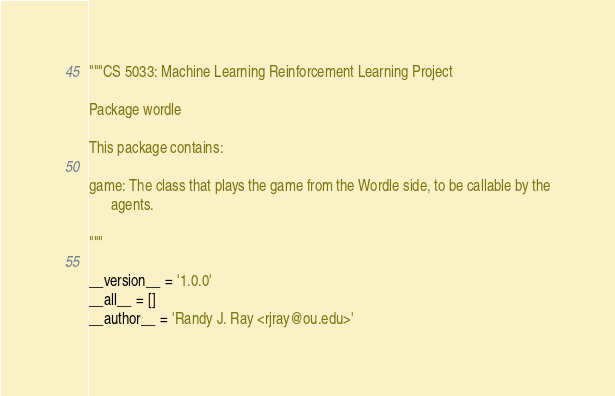<code> <loc_0><loc_0><loc_500><loc_500><_Python_>"""CS 5033: Machine Learning Reinforcement Learning Project

Package wordle

This package contains:

game: The class that plays the game from the Wordle side, to be callable by the
      agents.

"""

__version__ = '1.0.0'
__all__ = []
__author__ = 'Randy J. Ray <rjray@ou.edu>'
</code> 